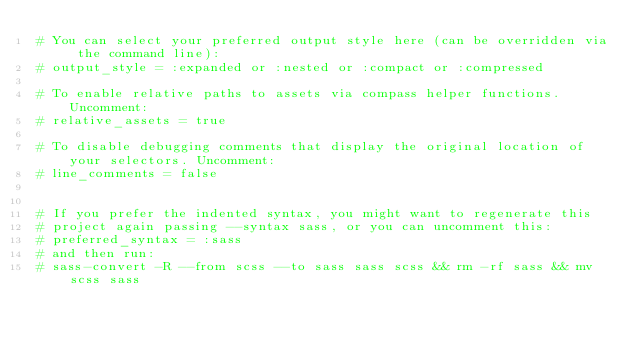Convert code to text. <code><loc_0><loc_0><loc_500><loc_500><_Ruby_># You can select your preferred output style here (can be overridden via the command line):
# output_style = :expanded or :nested or :compact or :compressed

# To enable relative paths to assets via compass helper functions. Uncomment:
# relative_assets = true

# To disable debugging comments that display the original location of your selectors. Uncomment:
# line_comments = false


# If you prefer the indented syntax, you might want to regenerate this
# project again passing --syntax sass, or you can uncomment this:
# preferred_syntax = :sass
# and then run:
# sass-convert -R --from scss --to sass sass scss && rm -rf sass && mv scss sass
</code> 